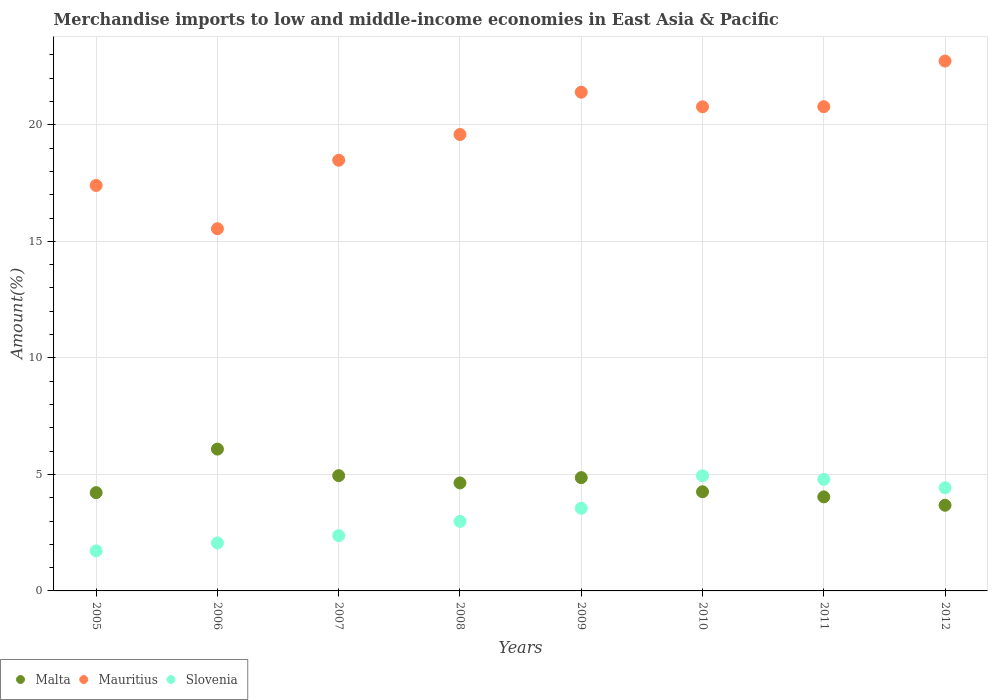How many different coloured dotlines are there?
Your answer should be very brief. 3. What is the percentage of amount earned from merchandise imports in Mauritius in 2005?
Offer a very short reply. 17.4. Across all years, what is the maximum percentage of amount earned from merchandise imports in Malta?
Your answer should be very brief. 6.09. Across all years, what is the minimum percentage of amount earned from merchandise imports in Mauritius?
Offer a very short reply. 15.54. In which year was the percentage of amount earned from merchandise imports in Slovenia minimum?
Your answer should be compact. 2005. What is the total percentage of amount earned from merchandise imports in Mauritius in the graph?
Offer a terse response. 156.71. What is the difference between the percentage of amount earned from merchandise imports in Slovenia in 2005 and that in 2010?
Offer a terse response. -3.22. What is the difference between the percentage of amount earned from merchandise imports in Slovenia in 2011 and the percentage of amount earned from merchandise imports in Mauritius in 2008?
Provide a succinct answer. -14.8. What is the average percentage of amount earned from merchandise imports in Malta per year?
Keep it short and to the point. 4.59. In the year 2011, what is the difference between the percentage of amount earned from merchandise imports in Mauritius and percentage of amount earned from merchandise imports in Slovenia?
Keep it short and to the point. 16. What is the ratio of the percentage of amount earned from merchandise imports in Slovenia in 2006 to that in 2011?
Offer a very short reply. 0.43. Is the percentage of amount earned from merchandise imports in Malta in 2010 less than that in 2011?
Ensure brevity in your answer.  No. What is the difference between the highest and the second highest percentage of amount earned from merchandise imports in Malta?
Ensure brevity in your answer.  1.14. What is the difference between the highest and the lowest percentage of amount earned from merchandise imports in Malta?
Give a very brief answer. 2.41. Does the percentage of amount earned from merchandise imports in Mauritius monotonically increase over the years?
Your answer should be very brief. No. How many dotlines are there?
Keep it short and to the point. 3. Are the values on the major ticks of Y-axis written in scientific E-notation?
Keep it short and to the point. No. Where does the legend appear in the graph?
Make the answer very short. Bottom left. What is the title of the graph?
Give a very brief answer. Merchandise imports to low and middle-income economies in East Asia & Pacific. Does "Afghanistan" appear as one of the legend labels in the graph?
Ensure brevity in your answer.  No. What is the label or title of the X-axis?
Provide a succinct answer. Years. What is the label or title of the Y-axis?
Your answer should be compact. Amount(%). What is the Amount(%) of Malta in 2005?
Offer a very short reply. 4.22. What is the Amount(%) of Mauritius in 2005?
Ensure brevity in your answer.  17.4. What is the Amount(%) in Slovenia in 2005?
Give a very brief answer. 1.72. What is the Amount(%) in Malta in 2006?
Provide a succinct answer. 6.09. What is the Amount(%) in Mauritius in 2006?
Offer a very short reply. 15.54. What is the Amount(%) of Slovenia in 2006?
Your response must be concise. 2.06. What is the Amount(%) of Malta in 2007?
Your response must be concise. 4.95. What is the Amount(%) in Mauritius in 2007?
Provide a succinct answer. 18.48. What is the Amount(%) in Slovenia in 2007?
Keep it short and to the point. 2.37. What is the Amount(%) of Malta in 2008?
Provide a short and direct response. 4.63. What is the Amount(%) of Mauritius in 2008?
Your answer should be compact. 19.59. What is the Amount(%) of Slovenia in 2008?
Your answer should be compact. 2.98. What is the Amount(%) of Malta in 2009?
Your answer should be compact. 4.86. What is the Amount(%) in Mauritius in 2009?
Provide a succinct answer. 21.4. What is the Amount(%) in Slovenia in 2009?
Provide a short and direct response. 3.55. What is the Amount(%) of Malta in 2010?
Your answer should be compact. 4.26. What is the Amount(%) in Mauritius in 2010?
Offer a terse response. 20.78. What is the Amount(%) in Slovenia in 2010?
Keep it short and to the point. 4.94. What is the Amount(%) in Malta in 2011?
Your answer should be compact. 4.04. What is the Amount(%) in Mauritius in 2011?
Your response must be concise. 20.78. What is the Amount(%) in Slovenia in 2011?
Your answer should be very brief. 4.79. What is the Amount(%) in Malta in 2012?
Provide a short and direct response. 3.68. What is the Amount(%) of Mauritius in 2012?
Make the answer very short. 22.74. What is the Amount(%) in Slovenia in 2012?
Your response must be concise. 4.43. Across all years, what is the maximum Amount(%) in Malta?
Offer a very short reply. 6.09. Across all years, what is the maximum Amount(%) of Mauritius?
Offer a terse response. 22.74. Across all years, what is the maximum Amount(%) in Slovenia?
Provide a succinct answer. 4.94. Across all years, what is the minimum Amount(%) of Malta?
Give a very brief answer. 3.68. Across all years, what is the minimum Amount(%) of Mauritius?
Your answer should be compact. 15.54. Across all years, what is the minimum Amount(%) in Slovenia?
Offer a very short reply. 1.72. What is the total Amount(%) of Malta in the graph?
Ensure brevity in your answer.  36.71. What is the total Amount(%) of Mauritius in the graph?
Provide a short and direct response. 156.71. What is the total Amount(%) in Slovenia in the graph?
Provide a short and direct response. 26.84. What is the difference between the Amount(%) in Malta in 2005 and that in 2006?
Give a very brief answer. -1.87. What is the difference between the Amount(%) in Mauritius in 2005 and that in 2006?
Your answer should be compact. 1.86. What is the difference between the Amount(%) of Slovenia in 2005 and that in 2006?
Give a very brief answer. -0.34. What is the difference between the Amount(%) of Malta in 2005 and that in 2007?
Provide a succinct answer. -0.73. What is the difference between the Amount(%) in Mauritius in 2005 and that in 2007?
Ensure brevity in your answer.  -1.08. What is the difference between the Amount(%) in Slovenia in 2005 and that in 2007?
Your response must be concise. -0.65. What is the difference between the Amount(%) of Malta in 2005 and that in 2008?
Your answer should be compact. -0.42. What is the difference between the Amount(%) in Mauritius in 2005 and that in 2008?
Offer a very short reply. -2.19. What is the difference between the Amount(%) of Slovenia in 2005 and that in 2008?
Keep it short and to the point. -1.26. What is the difference between the Amount(%) in Malta in 2005 and that in 2009?
Give a very brief answer. -0.64. What is the difference between the Amount(%) of Mauritius in 2005 and that in 2009?
Offer a very short reply. -4. What is the difference between the Amount(%) in Slovenia in 2005 and that in 2009?
Ensure brevity in your answer.  -1.83. What is the difference between the Amount(%) of Malta in 2005 and that in 2010?
Offer a very short reply. -0.04. What is the difference between the Amount(%) of Mauritius in 2005 and that in 2010?
Provide a short and direct response. -3.38. What is the difference between the Amount(%) of Slovenia in 2005 and that in 2010?
Provide a succinct answer. -3.22. What is the difference between the Amount(%) in Malta in 2005 and that in 2011?
Your answer should be very brief. 0.18. What is the difference between the Amount(%) of Mauritius in 2005 and that in 2011?
Ensure brevity in your answer.  -3.38. What is the difference between the Amount(%) in Slovenia in 2005 and that in 2011?
Provide a succinct answer. -3.07. What is the difference between the Amount(%) in Malta in 2005 and that in 2012?
Offer a terse response. 0.54. What is the difference between the Amount(%) in Mauritius in 2005 and that in 2012?
Provide a succinct answer. -5.34. What is the difference between the Amount(%) in Slovenia in 2005 and that in 2012?
Provide a short and direct response. -2.71. What is the difference between the Amount(%) in Malta in 2006 and that in 2007?
Offer a very short reply. 1.14. What is the difference between the Amount(%) of Mauritius in 2006 and that in 2007?
Offer a very short reply. -2.94. What is the difference between the Amount(%) in Slovenia in 2006 and that in 2007?
Give a very brief answer. -0.31. What is the difference between the Amount(%) in Malta in 2006 and that in 2008?
Give a very brief answer. 1.45. What is the difference between the Amount(%) in Mauritius in 2006 and that in 2008?
Your answer should be compact. -4.04. What is the difference between the Amount(%) in Slovenia in 2006 and that in 2008?
Your answer should be compact. -0.92. What is the difference between the Amount(%) of Malta in 2006 and that in 2009?
Offer a terse response. 1.23. What is the difference between the Amount(%) in Mauritius in 2006 and that in 2009?
Your response must be concise. -5.86. What is the difference between the Amount(%) of Slovenia in 2006 and that in 2009?
Your answer should be compact. -1.49. What is the difference between the Amount(%) of Malta in 2006 and that in 2010?
Your response must be concise. 1.83. What is the difference between the Amount(%) in Mauritius in 2006 and that in 2010?
Make the answer very short. -5.23. What is the difference between the Amount(%) of Slovenia in 2006 and that in 2010?
Provide a succinct answer. -2.88. What is the difference between the Amount(%) of Malta in 2006 and that in 2011?
Your answer should be very brief. 2.05. What is the difference between the Amount(%) of Mauritius in 2006 and that in 2011?
Provide a succinct answer. -5.24. What is the difference between the Amount(%) in Slovenia in 2006 and that in 2011?
Offer a very short reply. -2.73. What is the difference between the Amount(%) of Malta in 2006 and that in 2012?
Keep it short and to the point. 2.41. What is the difference between the Amount(%) in Mauritius in 2006 and that in 2012?
Provide a short and direct response. -7.2. What is the difference between the Amount(%) in Slovenia in 2006 and that in 2012?
Your answer should be compact. -2.37. What is the difference between the Amount(%) in Malta in 2007 and that in 2008?
Ensure brevity in your answer.  0.31. What is the difference between the Amount(%) in Mauritius in 2007 and that in 2008?
Your response must be concise. -1.1. What is the difference between the Amount(%) of Slovenia in 2007 and that in 2008?
Your answer should be compact. -0.61. What is the difference between the Amount(%) of Malta in 2007 and that in 2009?
Ensure brevity in your answer.  0.09. What is the difference between the Amount(%) of Mauritius in 2007 and that in 2009?
Offer a very short reply. -2.92. What is the difference between the Amount(%) of Slovenia in 2007 and that in 2009?
Offer a terse response. -1.17. What is the difference between the Amount(%) in Malta in 2007 and that in 2010?
Your response must be concise. 0.69. What is the difference between the Amount(%) in Mauritius in 2007 and that in 2010?
Provide a succinct answer. -2.29. What is the difference between the Amount(%) in Slovenia in 2007 and that in 2010?
Your response must be concise. -2.57. What is the difference between the Amount(%) of Malta in 2007 and that in 2011?
Offer a very short reply. 0.91. What is the difference between the Amount(%) in Mauritius in 2007 and that in 2011?
Keep it short and to the point. -2.3. What is the difference between the Amount(%) in Slovenia in 2007 and that in 2011?
Make the answer very short. -2.41. What is the difference between the Amount(%) in Malta in 2007 and that in 2012?
Keep it short and to the point. 1.27. What is the difference between the Amount(%) in Mauritius in 2007 and that in 2012?
Keep it short and to the point. -4.26. What is the difference between the Amount(%) in Slovenia in 2007 and that in 2012?
Your answer should be compact. -2.06. What is the difference between the Amount(%) in Malta in 2008 and that in 2009?
Give a very brief answer. -0.23. What is the difference between the Amount(%) in Mauritius in 2008 and that in 2009?
Make the answer very short. -1.82. What is the difference between the Amount(%) of Slovenia in 2008 and that in 2009?
Offer a very short reply. -0.56. What is the difference between the Amount(%) in Malta in 2008 and that in 2010?
Provide a short and direct response. 0.38. What is the difference between the Amount(%) of Mauritius in 2008 and that in 2010?
Offer a terse response. -1.19. What is the difference between the Amount(%) in Slovenia in 2008 and that in 2010?
Provide a short and direct response. -1.96. What is the difference between the Amount(%) in Malta in 2008 and that in 2011?
Keep it short and to the point. 0.6. What is the difference between the Amount(%) in Mauritius in 2008 and that in 2011?
Your answer should be very brief. -1.2. What is the difference between the Amount(%) in Slovenia in 2008 and that in 2011?
Offer a very short reply. -1.8. What is the difference between the Amount(%) in Mauritius in 2008 and that in 2012?
Offer a very short reply. -3.15. What is the difference between the Amount(%) in Slovenia in 2008 and that in 2012?
Offer a very short reply. -1.44. What is the difference between the Amount(%) in Malta in 2009 and that in 2010?
Your response must be concise. 0.61. What is the difference between the Amount(%) in Mauritius in 2009 and that in 2010?
Offer a very short reply. 0.63. What is the difference between the Amount(%) of Slovenia in 2009 and that in 2010?
Keep it short and to the point. -1.4. What is the difference between the Amount(%) in Malta in 2009 and that in 2011?
Make the answer very short. 0.83. What is the difference between the Amount(%) of Mauritius in 2009 and that in 2011?
Provide a succinct answer. 0.62. What is the difference between the Amount(%) of Slovenia in 2009 and that in 2011?
Offer a terse response. -1.24. What is the difference between the Amount(%) in Malta in 2009 and that in 2012?
Provide a succinct answer. 1.18. What is the difference between the Amount(%) in Mauritius in 2009 and that in 2012?
Give a very brief answer. -1.34. What is the difference between the Amount(%) of Slovenia in 2009 and that in 2012?
Provide a short and direct response. -0.88. What is the difference between the Amount(%) in Malta in 2010 and that in 2011?
Your answer should be compact. 0.22. What is the difference between the Amount(%) of Mauritius in 2010 and that in 2011?
Give a very brief answer. -0.01. What is the difference between the Amount(%) in Slovenia in 2010 and that in 2011?
Offer a terse response. 0.16. What is the difference between the Amount(%) of Malta in 2010 and that in 2012?
Give a very brief answer. 0.58. What is the difference between the Amount(%) in Mauritius in 2010 and that in 2012?
Offer a very short reply. -1.96. What is the difference between the Amount(%) of Slovenia in 2010 and that in 2012?
Provide a short and direct response. 0.51. What is the difference between the Amount(%) in Malta in 2011 and that in 2012?
Your response must be concise. 0.36. What is the difference between the Amount(%) of Mauritius in 2011 and that in 2012?
Keep it short and to the point. -1.96. What is the difference between the Amount(%) in Slovenia in 2011 and that in 2012?
Provide a short and direct response. 0.36. What is the difference between the Amount(%) of Malta in 2005 and the Amount(%) of Mauritius in 2006?
Offer a terse response. -11.33. What is the difference between the Amount(%) in Malta in 2005 and the Amount(%) in Slovenia in 2006?
Provide a succinct answer. 2.16. What is the difference between the Amount(%) in Mauritius in 2005 and the Amount(%) in Slovenia in 2006?
Make the answer very short. 15.34. What is the difference between the Amount(%) of Malta in 2005 and the Amount(%) of Mauritius in 2007?
Provide a short and direct response. -14.26. What is the difference between the Amount(%) in Malta in 2005 and the Amount(%) in Slovenia in 2007?
Offer a terse response. 1.84. What is the difference between the Amount(%) in Mauritius in 2005 and the Amount(%) in Slovenia in 2007?
Offer a very short reply. 15.03. What is the difference between the Amount(%) of Malta in 2005 and the Amount(%) of Mauritius in 2008?
Offer a terse response. -15.37. What is the difference between the Amount(%) in Malta in 2005 and the Amount(%) in Slovenia in 2008?
Ensure brevity in your answer.  1.23. What is the difference between the Amount(%) of Mauritius in 2005 and the Amount(%) of Slovenia in 2008?
Your answer should be compact. 14.42. What is the difference between the Amount(%) of Malta in 2005 and the Amount(%) of Mauritius in 2009?
Keep it short and to the point. -17.18. What is the difference between the Amount(%) in Malta in 2005 and the Amount(%) in Slovenia in 2009?
Your answer should be very brief. 0.67. What is the difference between the Amount(%) of Mauritius in 2005 and the Amount(%) of Slovenia in 2009?
Make the answer very short. 13.85. What is the difference between the Amount(%) of Malta in 2005 and the Amount(%) of Mauritius in 2010?
Provide a short and direct response. -16.56. What is the difference between the Amount(%) of Malta in 2005 and the Amount(%) of Slovenia in 2010?
Your answer should be very brief. -0.73. What is the difference between the Amount(%) of Mauritius in 2005 and the Amount(%) of Slovenia in 2010?
Offer a terse response. 12.46. What is the difference between the Amount(%) in Malta in 2005 and the Amount(%) in Mauritius in 2011?
Ensure brevity in your answer.  -16.56. What is the difference between the Amount(%) of Malta in 2005 and the Amount(%) of Slovenia in 2011?
Provide a short and direct response. -0.57. What is the difference between the Amount(%) in Mauritius in 2005 and the Amount(%) in Slovenia in 2011?
Your answer should be compact. 12.61. What is the difference between the Amount(%) of Malta in 2005 and the Amount(%) of Mauritius in 2012?
Your answer should be very brief. -18.52. What is the difference between the Amount(%) in Malta in 2005 and the Amount(%) in Slovenia in 2012?
Make the answer very short. -0.21. What is the difference between the Amount(%) in Mauritius in 2005 and the Amount(%) in Slovenia in 2012?
Your response must be concise. 12.97. What is the difference between the Amount(%) in Malta in 2006 and the Amount(%) in Mauritius in 2007?
Keep it short and to the point. -12.4. What is the difference between the Amount(%) of Malta in 2006 and the Amount(%) of Slovenia in 2007?
Give a very brief answer. 3.71. What is the difference between the Amount(%) in Mauritius in 2006 and the Amount(%) in Slovenia in 2007?
Keep it short and to the point. 13.17. What is the difference between the Amount(%) of Malta in 2006 and the Amount(%) of Mauritius in 2008?
Your answer should be compact. -13.5. What is the difference between the Amount(%) of Malta in 2006 and the Amount(%) of Slovenia in 2008?
Offer a terse response. 3.1. What is the difference between the Amount(%) of Mauritius in 2006 and the Amount(%) of Slovenia in 2008?
Your answer should be compact. 12.56. What is the difference between the Amount(%) of Malta in 2006 and the Amount(%) of Mauritius in 2009?
Ensure brevity in your answer.  -15.32. What is the difference between the Amount(%) of Malta in 2006 and the Amount(%) of Slovenia in 2009?
Offer a very short reply. 2.54. What is the difference between the Amount(%) of Mauritius in 2006 and the Amount(%) of Slovenia in 2009?
Offer a very short reply. 12. What is the difference between the Amount(%) of Malta in 2006 and the Amount(%) of Mauritius in 2010?
Make the answer very short. -14.69. What is the difference between the Amount(%) in Malta in 2006 and the Amount(%) in Slovenia in 2010?
Make the answer very short. 1.14. What is the difference between the Amount(%) in Mauritius in 2006 and the Amount(%) in Slovenia in 2010?
Provide a short and direct response. 10.6. What is the difference between the Amount(%) in Malta in 2006 and the Amount(%) in Mauritius in 2011?
Offer a very short reply. -14.7. What is the difference between the Amount(%) of Malta in 2006 and the Amount(%) of Slovenia in 2011?
Your response must be concise. 1.3. What is the difference between the Amount(%) of Mauritius in 2006 and the Amount(%) of Slovenia in 2011?
Provide a succinct answer. 10.76. What is the difference between the Amount(%) of Malta in 2006 and the Amount(%) of Mauritius in 2012?
Offer a terse response. -16.65. What is the difference between the Amount(%) of Malta in 2006 and the Amount(%) of Slovenia in 2012?
Your response must be concise. 1.66. What is the difference between the Amount(%) in Mauritius in 2006 and the Amount(%) in Slovenia in 2012?
Your answer should be compact. 11.11. What is the difference between the Amount(%) in Malta in 2007 and the Amount(%) in Mauritius in 2008?
Offer a very short reply. -14.64. What is the difference between the Amount(%) of Malta in 2007 and the Amount(%) of Slovenia in 2008?
Ensure brevity in your answer.  1.96. What is the difference between the Amount(%) in Mauritius in 2007 and the Amount(%) in Slovenia in 2008?
Your answer should be very brief. 15.5. What is the difference between the Amount(%) of Malta in 2007 and the Amount(%) of Mauritius in 2009?
Give a very brief answer. -16.46. What is the difference between the Amount(%) of Malta in 2007 and the Amount(%) of Slovenia in 2009?
Your answer should be compact. 1.4. What is the difference between the Amount(%) in Mauritius in 2007 and the Amount(%) in Slovenia in 2009?
Your answer should be compact. 14.94. What is the difference between the Amount(%) of Malta in 2007 and the Amount(%) of Mauritius in 2010?
Your response must be concise. -15.83. What is the difference between the Amount(%) of Malta in 2007 and the Amount(%) of Slovenia in 2010?
Provide a succinct answer. 0. What is the difference between the Amount(%) of Mauritius in 2007 and the Amount(%) of Slovenia in 2010?
Your answer should be compact. 13.54. What is the difference between the Amount(%) in Malta in 2007 and the Amount(%) in Mauritius in 2011?
Your answer should be compact. -15.84. What is the difference between the Amount(%) of Malta in 2007 and the Amount(%) of Slovenia in 2011?
Ensure brevity in your answer.  0.16. What is the difference between the Amount(%) in Mauritius in 2007 and the Amount(%) in Slovenia in 2011?
Keep it short and to the point. 13.7. What is the difference between the Amount(%) of Malta in 2007 and the Amount(%) of Mauritius in 2012?
Your answer should be compact. -17.79. What is the difference between the Amount(%) in Malta in 2007 and the Amount(%) in Slovenia in 2012?
Your answer should be very brief. 0.52. What is the difference between the Amount(%) of Mauritius in 2007 and the Amount(%) of Slovenia in 2012?
Provide a short and direct response. 14.05. What is the difference between the Amount(%) in Malta in 2008 and the Amount(%) in Mauritius in 2009?
Your response must be concise. -16.77. What is the difference between the Amount(%) of Malta in 2008 and the Amount(%) of Slovenia in 2009?
Offer a terse response. 1.09. What is the difference between the Amount(%) in Mauritius in 2008 and the Amount(%) in Slovenia in 2009?
Ensure brevity in your answer.  16.04. What is the difference between the Amount(%) in Malta in 2008 and the Amount(%) in Mauritius in 2010?
Make the answer very short. -16.14. What is the difference between the Amount(%) of Malta in 2008 and the Amount(%) of Slovenia in 2010?
Provide a succinct answer. -0.31. What is the difference between the Amount(%) in Mauritius in 2008 and the Amount(%) in Slovenia in 2010?
Give a very brief answer. 14.64. What is the difference between the Amount(%) of Malta in 2008 and the Amount(%) of Mauritius in 2011?
Offer a very short reply. -16.15. What is the difference between the Amount(%) in Malta in 2008 and the Amount(%) in Slovenia in 2011?
Your answer should be compact. -0.15. What is the difference between the Amount(%) of Mauritius in 2008 and the Amount(%) of Slovenia in 2011?
Offer a very short reply. 14.8. What is the difference between the Amount(%) in Malta in 2008 and the Amount(%) in Mauritius in 2012?
Ensure brevity in your answer.  -18.1. What is the difference between the Amount(%) of Malta in 2008 and the Amount(%) of Slovenia in 2012?
Your answer should be very brief. 0.21. What is the difference between the Amount(%) in Mauritius in 2008 and the Amount(%) in Slovenia in 2012?
Give a very brief answer. 15.16. What is the difference between the Amount(%) in Malta in 2009 and the Amount(%) in Mauritius in 2010?
Provide a succinct answer. -15.91. What is the difference between the Amount(%) in Malta in 2009 and the Amount(%) in Slovenia in 2010?
Provide a short and direct response. -0.08. What is the difference between the Amount(%) of Mauritius in 2009 and the Amount(%) of Slovenia in 2010?
Give a very brief answer. 16.46. What is the difference between the Amount(%) in Malta in 2009 and the Amount(%) in Mauritius in 2011?
Provide a succinct answer. -15.92. What is the difference between the Amount(%) of Malta in 2009 and the Amount(%) of Slovenia in 2011?
Your answer should be compact. 0.07. What is the difference between the Amount(%) of Mauritius in 2009 and the Amount(%) of Slovenia in 2011?
Provide a succinct answer. 16.62. What is the difference between the Amount(%) of Malta in 2009 and the Amount(%) of Mauritius in 2012?
Ensure brevity in your answer.  -17.88. What is the difference between the Amount(%) of Malta in 2009 and the Amount(%) of Slovenia in 2012?
Give a very brief answer. 0.43. What is the difference between the Amount(%) in Mauritius in 2009 and the Amount(%) in Slovenia in 2012?
Give a very brief answer. 16.97. What is the difference between the Amount(%) in Malta in 2010 and the Amount(%) in Mauritius in 2011?
Offer a terse response. -16.53. What is the difference between the Amount(%) of Malta in 2010 and the Amount(%) of Slovenia in 2011?
Your answer should be compact. -0.53. What is the difference between the Amount(%) in Mauritius in 2010 and the Amount(%) in Slovenia in 2011?
Your answer should be very brief. 15.99. What is the difference between the Amount(%) of Malta in 2010 and the Amount(%) of Mauritius in 2012?
Keep it short and to the point. -18.48. What is the difference between the Amount(%) of Malta in 2010 and the Amount(%) of Slovenia in 2012?
Your answer should be very brief. -0.17. What is the difference between the Amount(%) in Mauritius in 2010 and the Amount(%) in Slovenia in 2012?
Your answer should be compact. 16.35. What is the difference between the Amount(%) of Malta in 2011 and the Amount(%) of Mauritius in 2012?
Ensure brevity in your answer.  -18.7. What is the difference between the Amount(%) of Malta in 2011 and the Amount(%) of Slovenia in 2012?
Give a very brief answer. -0.39. What is the difference between the Amount(%) of Mauritius in 2011 and the Amount(%) of Slovenia in 2012?
Provide a short and direct response. 16.35. What is the average Amount(%) of Malta per year?
Give a very brief answer. 4.59. What is the average Amount(%) in Mauritius per year?
Provide a short and direct response. 19.59. What is the average Amount(%) in Slovenia per year?
Your response must be concise. 3.36. In the year 2005, what is the difference between the Amount(%) of Malta and Amount(%) of Mauritius?
Ensure brevity in your answer.  -13.18. In the year 2005, what is the difference between the Amount(%) of Malta and Amount(%) of Slovenia?
Make the answer very short. 2.5. In the year 2005, what is the difference between the Amount(%) in Mauritius and Amount(%) in Slovenia?
Offer a very short reply. 15.68. In the year 2006, what is the difference between the Amount(%) of Malta and Amount(%) of Mauritius?
Make the answer very short. -9.46. In the year 2006, what is the difference between the Amount(%) of Malta and Amount(%) of Slovenia?
Offer a very short reply. 4.03. In the year 2006, what is the difference between the Amount(%) in Mauritius and Amount(%) in Slovenia?
Offer a terse response. 13.48. In the year 2007, what is the difference between the Amount(%) of Malta and Amount(%) of Mauritius?
Offer a very short reply. -13.54. In the year 2007, what is the difference between the Amount(%) in Malta and Amount(%) in Slovenia?
Provide a succinct answer. 2.57. In the year 2007, what is the difference between the Amount(%) in Mauritius and Amount(%) in Slovenia?
Offer a very short reply. 16.11. In the year 2008, what is the difference between the Amount(%) in Malta and Amount(%) in Mauritius?
Make the answer very short. -14.95. In the year 2008, what is the difference between the Amount(%) of Malta and Amount(%) of Slovenia?
Make the answer very short. 1.65. In the year 2008, what is the difference between the Amount(%) of Mauritius and Amount(%) of Slovenia?
Your response must be concise. 16.6. In the year 2009, what is the difference between the Amount(%) of Malta and Amount(%) of Mauritius?
Provide a succinct answer. -16.54. In the year 2009, what is the difference between the Amount(%) of Malta and Amount(%) of Slovenia?
Your answer should be compact. 1.31. In the year 2009, what is the difference between the Amount(%) of Mauritius and Amount(%) of Slovenia?
Your answer should be very brief. 17.86. In the year 2010, what is the difference between the Amount(%) of Malta and Amount(%) of Mauritius?
Make the answer very short. -16.52. In the year 2010, what is the difference between the Amount(%) in Malta and Amount(%) in Slovenia?
Give a very brief answer. -0.69. In the year 2010, what is the difference between the Amount(%) of Mauritius and Amount(%) of Slovenia?
Provide a short and direct response. 15.83. In the year 2011, what is the difference between the Amount(%) in Malta and Amount(%) in Mauritius?
Give a very brief answer. -16.75. In the year 2011, what is the difference between the Amount(%) in Malta and Amount(%) in Slovenia?
Your response must be concise. -0.75. In the year 2011, what is the difference between the Amount(%) in Mauritius and Amount(%) in Slovenia?
Ensure brevity in your answer.  16. In the year 2012, what is the difference between the Amount(%) of Malta and Amount(%) of Mauritius?
Your answer should be compact. -19.06. In the year 2012, what is the difference between the Amount(%) in Malta and Amount(%) in Slovenia?
Offer a very short reply. -0.75. In the year 2012, what is the difference between the Amount(%) in Mauritius and Amount(%) in Slovenia?
Your response must be concise. 18.31. What is the ratio of the Amount(%) in Malta in 2005 to that in 2006?
Give a very brief answer. 0.69. What is the ratio of the Amount(%) of Mauritius in 2005 to that in 2006?
Give a very brief answer. 1.12. What is the ratio of the Amount(%) of Slovenia in 2005 to that in 2006?
Provide a succinct answer. 0.83. What is the ratio of the Amount(%) of Malta in 2005 to that in 2007?
Provide a succinct answer. 0.85. What is the ratio of the Amount(%) of Mauritius in 2005 to that in 2007?
Make the answer very short. 0.94. What is the ratio of the Amount(%) of Slovenia in 2005 to that in 2007?
Make the answer very short. 0.72. What is the ratio of the Amount(%) of Malta in 2005 to that in 2008?
Keep it short and to the point. 0.91. What is the ratio of the Amount(%) of Mauritius in 2005 to that in 2008?
Offer a terse response. 0.89. What is the ratio of the Amount(%) in Slovenia in 2005 to that in 2008?
Offer a terse response. 0.58. What is the ratio of the Amount(%) of Malta in 2005 to that in 2009?
Provide a succinct answer. 0.87. What is the ratio of the Amount(%) of Mauritius in 2005 to that in 2009?
Provide a succinct answer. 0.81. What is the ratio of the Amount(%) of Slovenia in 2005 to that in 2009?
Your response must be concise. 0.48. What is the ratio of the Amount(%) of Malta in 2005 to that in 2010?
Your answer should be very brief. 0.99. What is the ratio of the Amount(%) of Mauritius in 2005 to that in 2010?
Ensure brevity in your answer.  0.84. What is the ratio of the Amount(%) of Slovenia in 2005 to that in 2010?
Keep it short and to the point. 0.35. What is the ratio of the Amount(%) in Malta in 2005 to that in 2011?
Keep it short and to the point. 1.05. What is the ratio of the Amount(%) in Mauritius in 2005 to that in 2011?
Make the answer very short. 0.84. What is the ratio of the Amount(%) of Slovenia in 2005 to that in 2011?
Your answer should be compact. 0.36. What is the ratio of the Amount(%) in Malta in 2005 to that in 2012?
Offer a very short reply. 1.15. What is the ratio of the Amount(%) in Mauritius in 2005 to that in 2012?
Give a very brief answer. 0.77. What is the ratio of the Amount(%) in Slovenia in 2005 to that in 2012?
Your answer should be very brief. 0.39. What is the ratio of the Amount(%) in Malta in 2006 to that in 2007?
Provide a succinct answer. 1.23. What is the ratio of the Amount(%) of Mauritius in 2006 to that in 2007?
Give a very brief answer. 0.84. What is the ratio of the Amount(%) of Slovenia in 2006 to that in 2007?
Your answer should be very brief. 0.87. What is the ratio of the Amount(%) of Malta in 2006 to that in 2008?
Give a very brief answer. 1.31. What is the ratio of the Amount(%) of Mauritius in 2006 to that in 2008?
Offer a terse response. 0.79. What is the ratio of the Amount(%) of Slovenia in 2006 to that in 2008?
Offer a terse response. 0.69. What is the ratio of the Amount(%) in Malta in 2006 to that in 2009?
Your response must be concise. 1.25. What is the ratio of the Amount(%) of Mauritius in 2006 to that in 2009?
Offer a terse response. 0.73. What is the ratio of the Amount(%) of Slovenia in 2006 to that in 2009?
Make the answer very short. 0.58. What is the ratio of the Amount(%) of Malta in 2006 to that in 2010?
Your response must be concise. 1.43. What is the ratio of the Amount(%) of Mauritius in 2006 to that in 2010?
Your response must be concise. 0.75. What is the ratio of the Amount(%) in Slovenia in 2006 to that in 2010?
Offer a very short reply. 0.42. What is the ratio of the Amount(%) in Malta in 2006 to that in 2011?
Provide a short and direct response. 1.51. What is the ratio of the Amount(%) of Mauritius in 2006 to that in 2011?
Give a very brief answer. 0.75. What is the ratio of the Amount(%) in Slovenia in 2006 to that in 2011?
Keep it short and to the point. 0.43. What is the ratio of the Amount(%) in Malta in 2006 to that in 2012?
Offer a very short reply. 1.66. What is the ratio of the Amount(%) of Mauritius in 2006 to that in 2012?
Your answer should be compact. 0.68. What is the ratio of the Amount(%) of Slovenia in 2006 to that in 2012?
Your response must be concise. 0.47. What is the ratio of the Amount(%) in Malta in 2007 to that in 2008?
Your answer should be compact. 1.07. What is the ratio of the Amount(%) in Mauritius in 2007 to that in 2008?
Make the answer very short. 0.94. What is the ratio of the Amount(%) of Slovenia in 2007 to that in 2008?
Ensure brevity in your answer.  0.8. What is the ratio of the Amount(%) of Malta in 2007 to that in 2009?
Offer a very short reply. 1.02. What is the ratio of the Amount(%) of Mauritius in 2007 to that in 2009?
Ensure brevity in your answer.  0.86. What is the ratio of the Amount(%) in Slovenia in 2007 to that in 2009?
Your answer should be compact. 0.67. What is the ratio of the Amount(%) in Malta in 2007 to that in 2010?
Keep it short and to the point. 1.16. What is the ratio of the Amount(%) of Mauritius in 2007 to that in 2010?
Make the answer very short. 0.89. What is the ratio of the Amount(%) of Slovenia in 2007 to that in 2010?
Offer a terse response. 0.48. What is the ratio of the Amount(%) of Malta in 2007 to that in 2011?
Offer a very short reply. 1.23. What is the ratio of the Amount(%) in Mauritius in 2007 to that in 2011?
Offer a terse response. 0.89. What is the ratio of the Amount(%) in Slovenia in 2007 to that in 2011?
Your response must be concise. 0.5. What is the ratio of the Amount(%) in Malta in 2007 to that in 2012?
Make the answer very short. 1.35. What is the ratio of the Amount(%) of Mauritius in 2007 to that in 2012?
Provide a short and direct response. 0.81. What is the ratio of the Amount(%) in Slovenia in 2007 to that in 2012?
Ensure brevity in your answer.  0.54. What is the ratio of the Amount(%) in Malta in 2008 to that in 2009?
Your answer should be very brief. 0.95. What is the ratio of the Amount(%) of Mauritius in 2008 to that in 2009?
Your answer should be very brief. 0.92. What is the ratio of the Amount(%) of Slovenia in 2008 to that in 2009?
Give a very brief answer. 0.84. What is the ratio of the Amount(%) of Malta in 2008 to that in 2010?
Your response must be concise. 1.09. What is the ratio of the Amount(%) in Mauritius in 2008 to that in 2010?
Provide a short and direct response. 0.94. What is the ratio of the Amount(%) of Slovenia in 2008 to that in 2010?
Provide a succinct answer. 0.6. What is the ratio of the Amount(%) of Malta in 2008 to that in 2011?
Your answer should be very brief. 1.15. What is the ratio of the Amount(%) in Mauritius in 2008 to that in 2011?
Give a very brief answer. 0.94. What is the ratio of the Amount(%) in Slovenia in 2008 to that in 2011?
Make the answer very short. 0.62. What is the ratio of the Amount(%) of Malta in 2008 to that in 2012?
Provide a short and direct response. 1.26. What is the ratio of the Amount(%) of Mauritius in 2008 to that in 2012?
Your answer should be compact. 0.86. What is the ratio of the Amount(%) in Slovenia in 2008 to that in 2012?
Your response must be concise. 0.67. What is the ratio of the Amount(%) of Malta in 2009 to that in 2010?
Make the answer very short. 1.14. What is the ratio of the Amount(%) in Mauritius in 2009 to that in 2010?
Provide a short and direct response. 1.03. What is the ratio of the Amount(%) of Slovenia in 2009 to that in 2010?
Keep it short and to the point. 0.72. What is the ratio of the Amount(%) of Malta in 2009 to that in 2011?
Offer a very short reply. 1.2. What is the ratio of the Amount(%) of Mauritius in 2009 to that in 2011?
Provide a short and direct response. 1.03. What is the ratio of the Amount(%) of Slovenia in 2009 to that in 2011?
Provide a succinct answer. 0.74. What is the ratio of the Amount(%) in Malta in 2009 to that in 2012?
Make the answer very short. 1.32. What is the ratio of the Amount(%) in Slovenia in 2009 to that in 2012?
Your answer should be compact. 0.8. What is the ratio of the Amount(%) of Malta in 2010 to that in 2011?
Your answer should be very brief. 1.05. What is the ratio of the Amount(%) in Mauritius in 2010 to that in 2011?
Keep it short and to the point. 1. What is the ratio of the Amount(%) of Slovenia in 2010 to that in 2011?
Make the answer very short. 1.03. What is the ratio of the Amount(%) of Malta in 2010 to that in 2012?
Offer a very short reply. 1.16. What is the ratio of the Amount(%) of Mauritius in 2010 to that in 2012?
Your answer should be compact. 0.91. What is the ratio of the Amount(%) of Slovenia in 2010 to that in 2012?
Give a very brief answer. 1.12. What is the ratio of the Amount(%) in Malta in 2011 to that in 2012?
Offer a very short reply. 1.1. What is the ratio of the Amount(%) of Mauritius in 2011 to that in 2012?
Make the answer very short. 0.91. What is the ratio of the Amount(%) in Slovenia in 2011 to that in 2012?
Offer a very short reply. 1.08. What is the difference between the highest and the second highest Amount(%) in Malta?
Your answer should be compact. 1.14. What is the difference between the highest and the second highest Amount(%) of Mauritius?
Your answer should be compact. 1.34. What is the difference between the highest and the second highest Amount(%) of Slovenia?
Your response must be concise. 0.16. What is the difference between the highest and the lowest Amount(%) in Malta?
Your answer should be very brief. 2.41. What is the difference between the highest and the lowest Amount(%) in Mauritius?
Ensure brevity in your answer.  7.2. What is the difference between the highest and the lowest Amount(%) of Slovenia?
Make the answer very short. 3.22. 